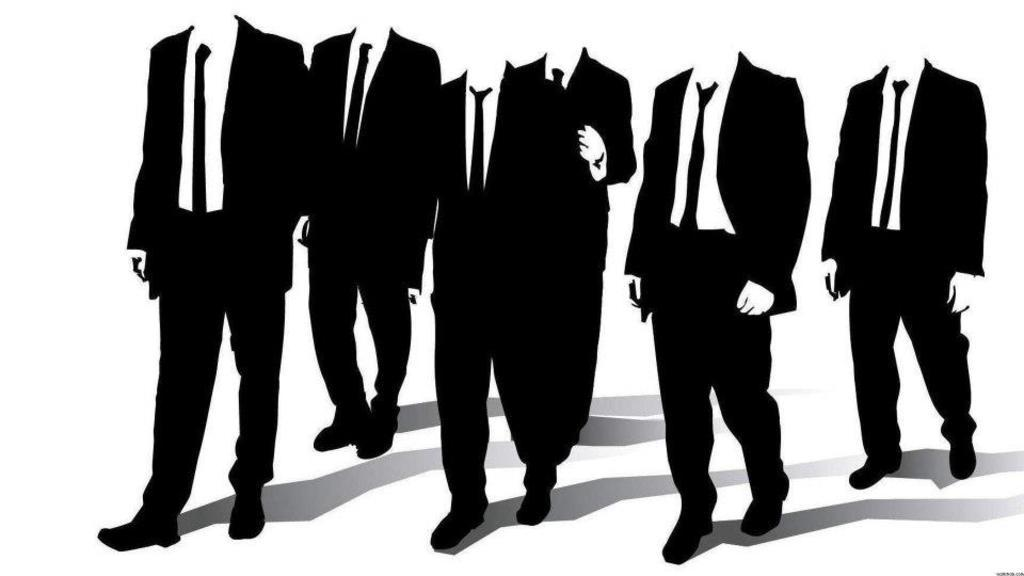What can be seen in the image? There are depictions of persons in the image. What type of milk is being used for driving in the image? There is no milk or driving present in the image; it only features depictions of persons. 